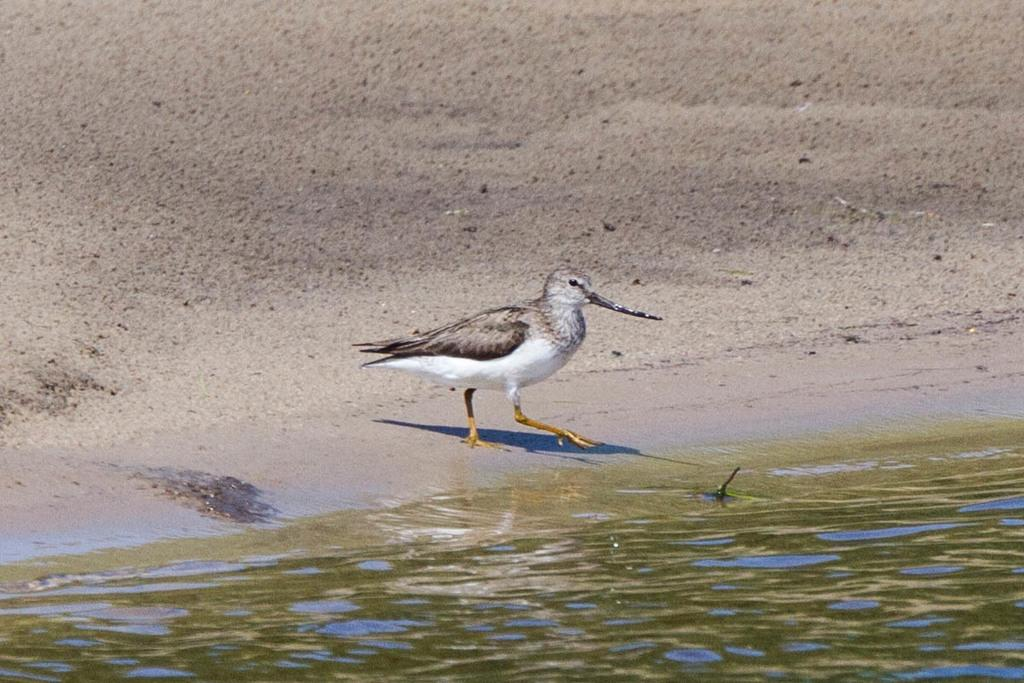What is visible in the image? There is water visible in the image. What type of animal can be seen in the image? There is a bird in the center of the image. What type of caption is written under the bird in the image? There is no caption written under the bird in the image. Can you tell me how the bird is playing the guitar in the image? There is no guitar present in the image, and therefore the bird is not playing any instrument. 